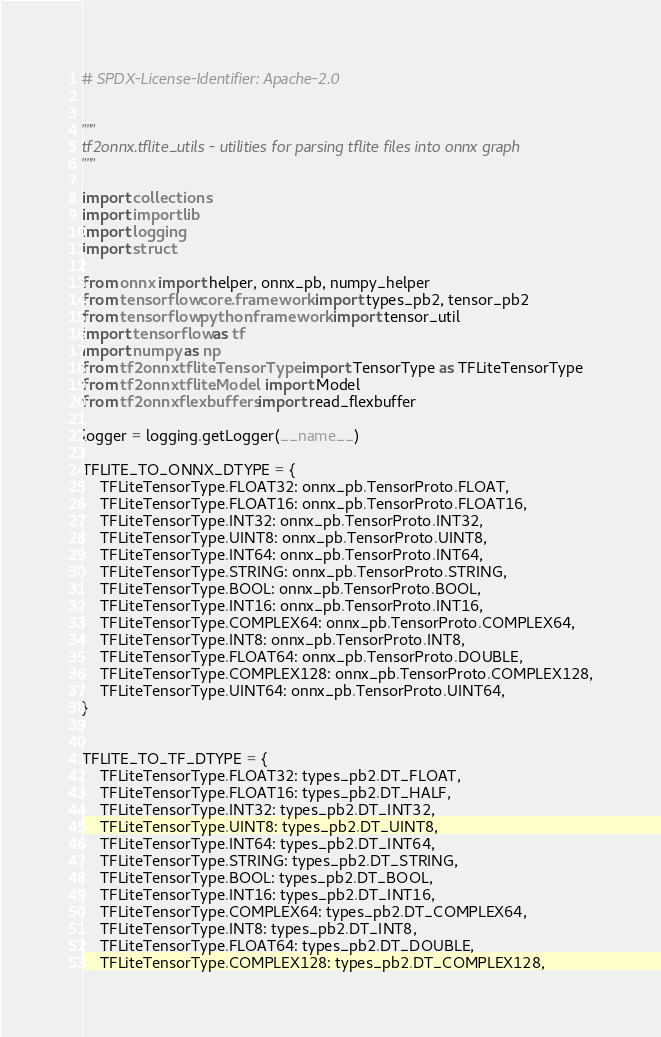<code> <loc_0><loc_0><loc_500><loc_500><_Python_># SPDX-License-Identifier: Apache-2.0


"""
tf2onnx.tflite_utils - utilities for parsing tflite files into onnx graph
"""

import collections
import importlib
import logging
import struct

from onnx import helper, onnx_pb, numpy_helper
from tensorflow.core.framework import types_pb2, tensor_pb2
from tensorflow.python.framework import tensor_util
import tensorflow as tf
import numpy as np
from tf2onnx.tflite.TensorType import TensorType as TFLiteTensorType
from tf2onnx.tflite.Model import Model
from tf2onnx.flexbuffers import read_flexbuffer

logger = logging.getLogger(__name__)

TFLITE_TO_ONNX_DTYPE = {
    TFLiteTensorType.FLOAT32: onnx_pb.TensorProto.FLOAT,
    TFLiteTensorType.FLOAT16: onnx_pb.TensorProto.FLOAT16,
    TFLiteTensorType.INT32: onnx_pb.TensorProto.INT32,
    TFLiteTensorType.UINT8: onnx_pb.TensorProto.UINT8,
    TFLiteTensorType.INT64: onnx_pb.TensorProto.INT64,
    TFLiteTensorType.STRING: onnx_pb.TensorProto.STRING,
    TFLiteTensorType.BOOL: onnx_pb.TensorProto.BOOL,
    TFLiteTensorType.INT16: onnx_pb.TensorProto.INT16,
    TFLiteTensorType.COMPLEX64: onnx_pb.TensorProto.COMPLEX64,
    TFLiteTensorType.INT8: onnx_pb.TensorProto.INT8,
    TFLiteTensorType.FLOAT64: onnx_pb.TensorProto.DOUBLE,
    TFLiteTensorType.COMPLEX128: onnx_pb.TensorProto.COMPLEX128,
    TFLiteTensorType.UINT64: onnx_pb.TensorProto.UINT64,
}


TFLITE_TO_TF_DTYPE = {
    TFLiteTensorType.FLOAT32: types_pb2.DT_FLOAT,
    TFLiteTensorType.FLOAT16: types_pb2.DT_HALF,
    TFLiteTensorType.INT32: types_pb2.DT_INT32,
    TFLiteTensorType.UINT8: types_pb2.DT_UINT8,
    TFLiteTensorType.INT64: types_pb2.DT_INT64,
    TFLiteTensorType.STRING: types_pb2.DT_STRING,
    TFLiteTensorType.BOOL: types_pb2.DT_BOOL,
    TFLiteTensorType.INT16: types_pb2.DT_INT16,
    TFLiteTensorType.COMPLEX64: types_pb2.DT_COMPLEX64,
    TFLiteTensorType.INT8: types_pb2.DT_INT8,
    TFLiteTensorType.FLOAT64: types_pb2.DT_DOUBLE,
    TFLiteTensorType.COMPLEX128: types_pb2.DT_COMPLEX128,</code> 